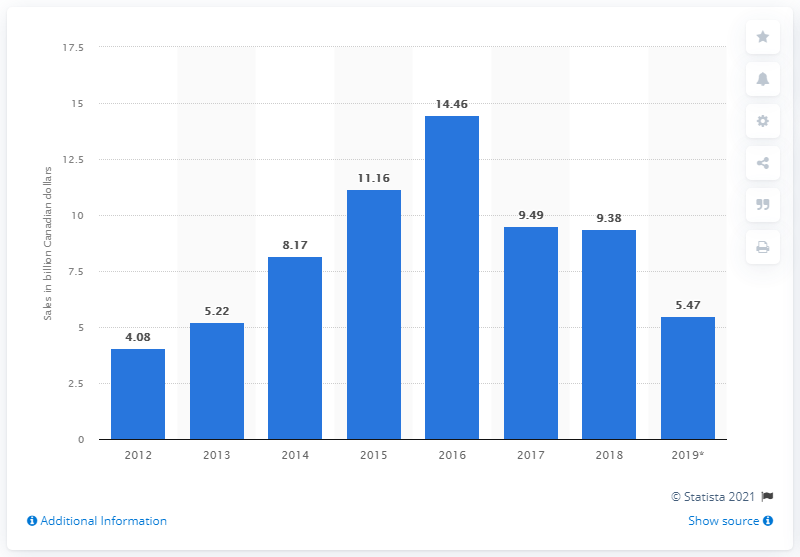List a handful of essential elements in this visual. The total retail sales of Hudson's Bay Company in the third quarter of 2019 were 5.47. In the third quarter of 2019, the retail sales of Hudson's Bay Company in Canada were CAD 5.47 billion. 